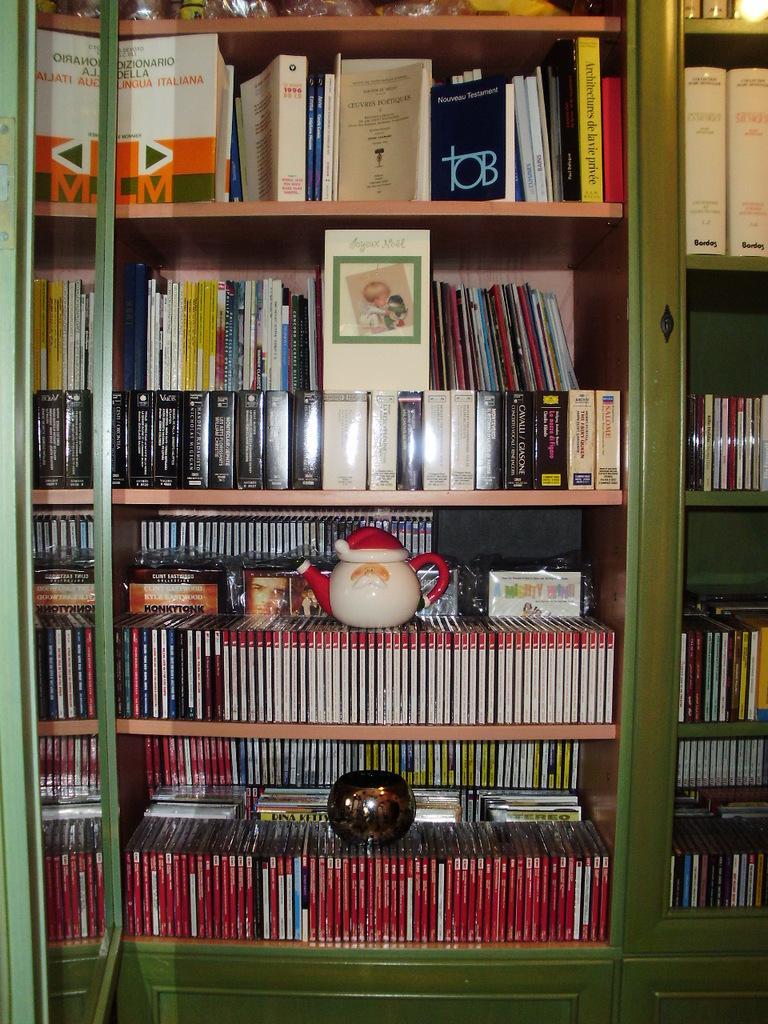Could you give a brief overview of what you see in this image? In this image there is a book rack. Here there is a kettle. 